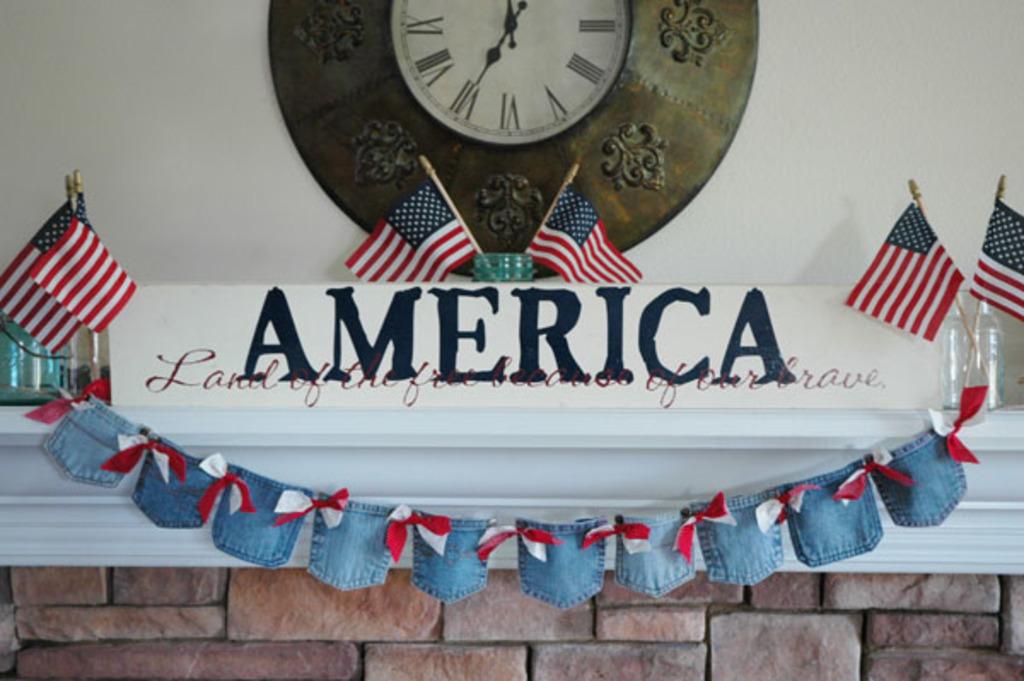What country is being celebrated in this banner?
Your response must be concise. America. America is land of the free and home of the ?
Make the answer very short. Brave. 